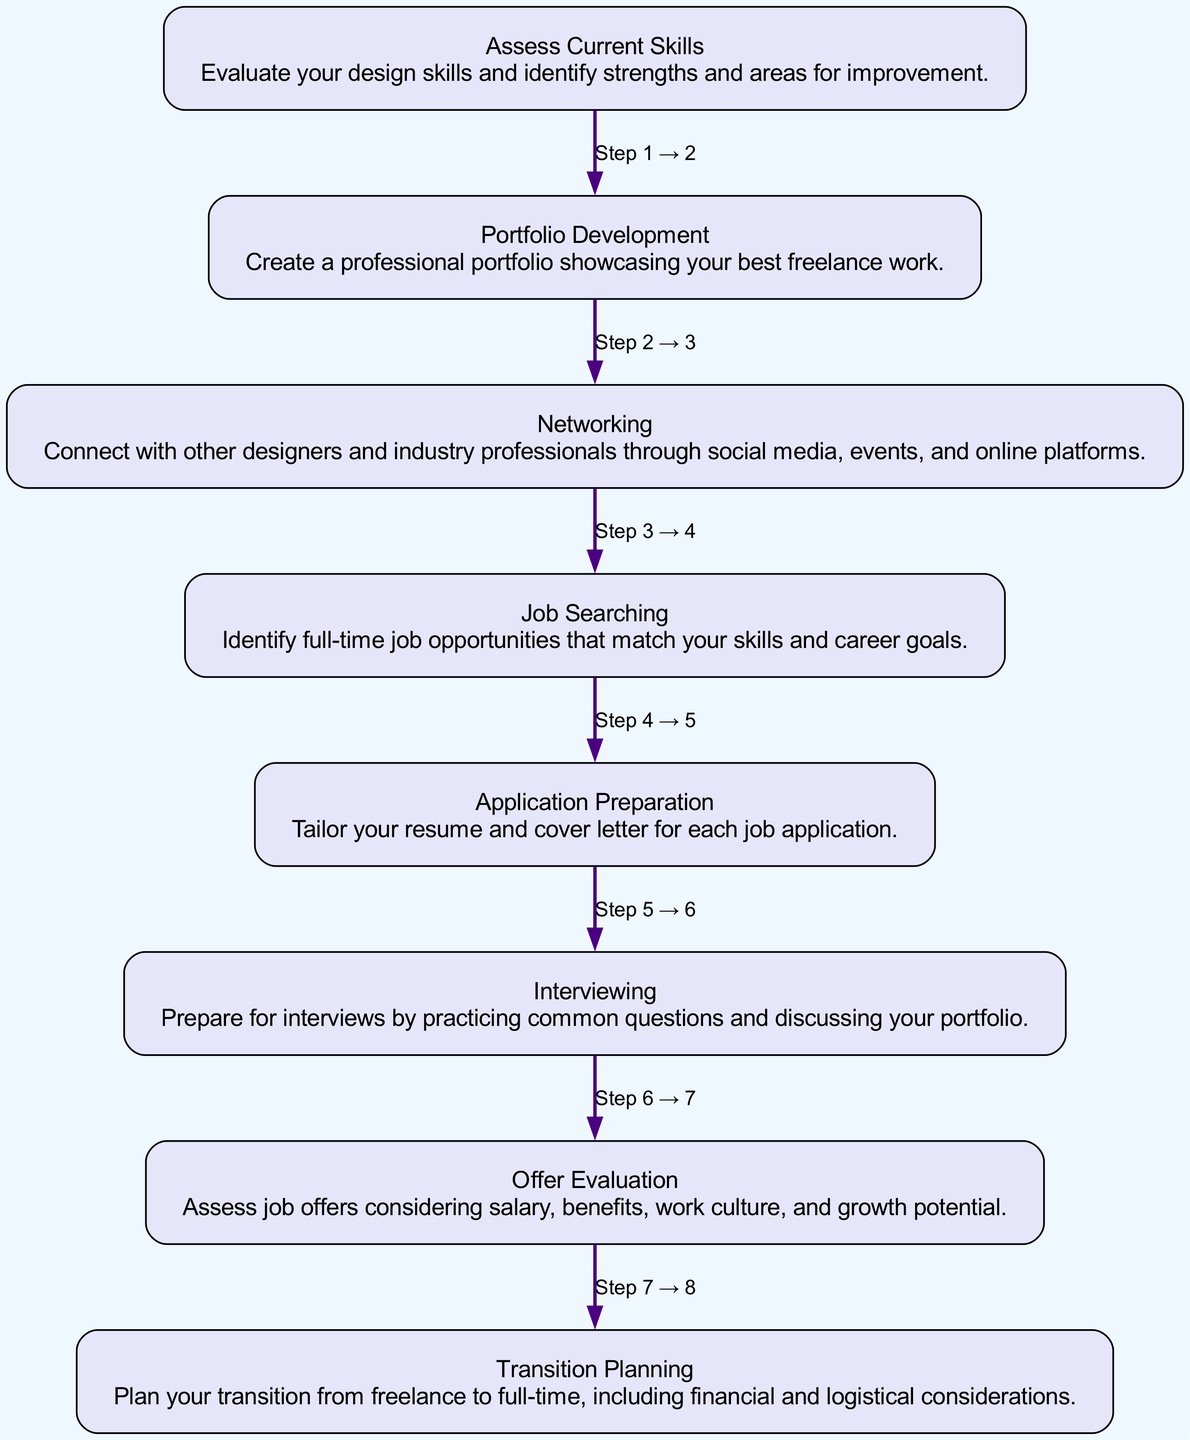What is the first step in the transition process? The first step listed in the diagram is "Assess Current Skills." This is determined by looking at the flow chart and identifying the node at the top or closest to the starting point.
Answer: Assess Current Skills How many total steps are there in the diagram? By counting all the nodes in the flow chart, there are eight distinct steps. This can be done visually by enumerating each node from top to bottom.
Answer: Eight What comes after "Portfolio Development"? According to the flow of the diagram, the step that follows "Portfolio Development" is "Networking," as indicated by the directed edge connecting the two nodes.
Answer: Networking Which step involves evaluating job offers? The step that involves evaluating job offers is "Offer Evaluation," identified by looking at the corresponding node that specifically addresses job offers and related considerations.
Answer: Offer Evaluation What is the last step in the transition process? The last step in the diagram is "Transition Planning." This can be confirmed by identifying the endpoint node at the bottom of the flow chart.
Answer: Transition Planning Which two steps are directly connected by an edge labeled "Step 3 → 4"? The edge labeled "Step 3 → 4" connects "Networking" to "Job Searching." This is verified by following the labeled edge in the flow chart linking those two specific steps sequentially.
Answer: Networking and Job Searching What is the purpose of the "Interviewing" step? The purpose of the "Interviewing" step is to prepare for interviews by practicing common questions and discussing your portfolio. This can be deduced from the detailed description within that node.
Answer: Prepare for interviews Which step requires tailoring documents? The step that requires tailoring documents is "Application Preparation," which can be found by checking the node that mentions the need for customizing the resume and cover letter for job applications.
Answer: Application Preparation 